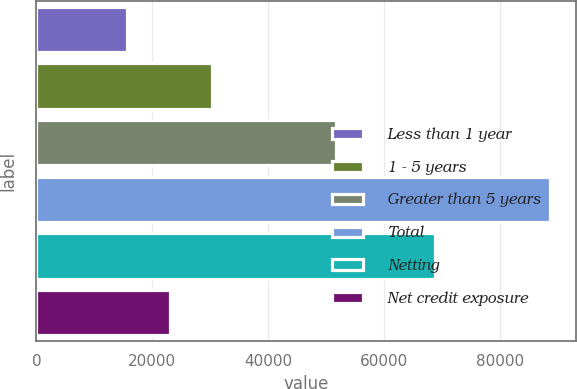Convert chart. <chart><loc_0><loc_0><loc_500><loc_500><bar_chart><fcel>Less than 1 year<fcel>1 - 5 years<fcel>Greater than 5 years<fcel>Total<fcel>Netting<fcel>Net credit exposure<nl><fcel>15697<fcel>30304.4<fcel>51737<fcel>88734<fcel>68736<fcel>23000.7<nl></chart> 